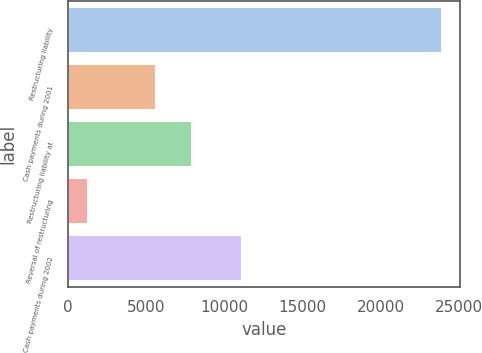Convert chart. <chart><loc_0><loc_0><loc_500><loc_500><bar_chart><fcel>Restructuring liability<fcel>Cash payments during 2001<fcel>Restructuring liability at<fcel>Reversal of restructuring<fcel>Cash payments during 2002<nl><fcel>23877<fcel>5644<fcel>7903.2<fcel>1285<fcel>11118<nl></chart> 